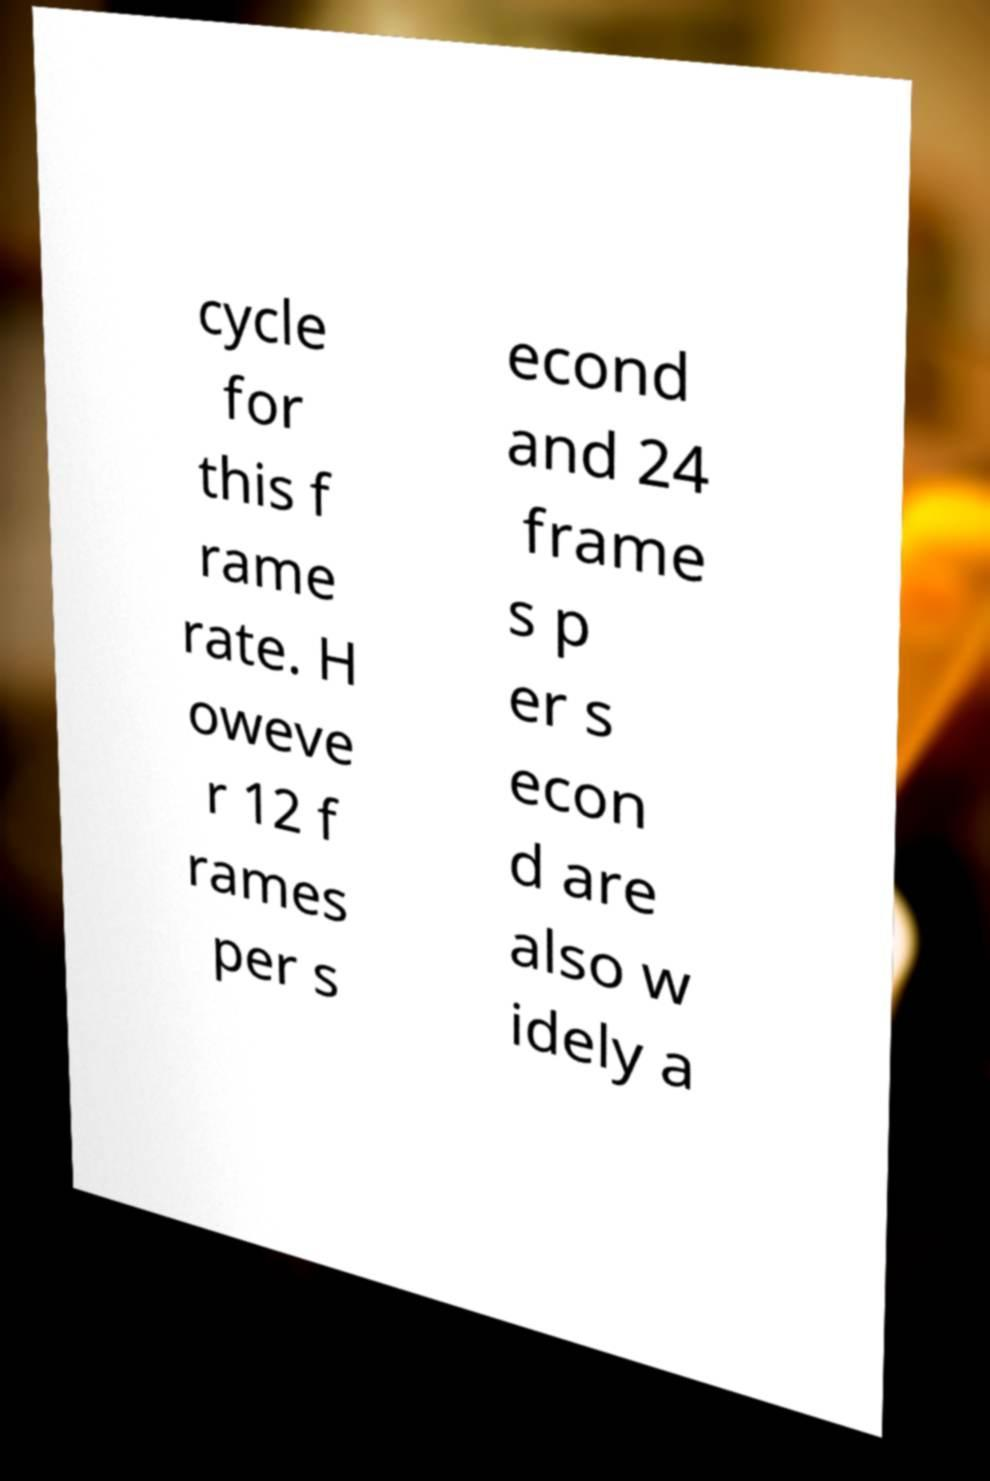Please read and relay the text visible in this image. What does it say? cycle for this f rame rate. H oweve r 12 f rames per s econd and 24 frame s p er s econ d are also w idely a 